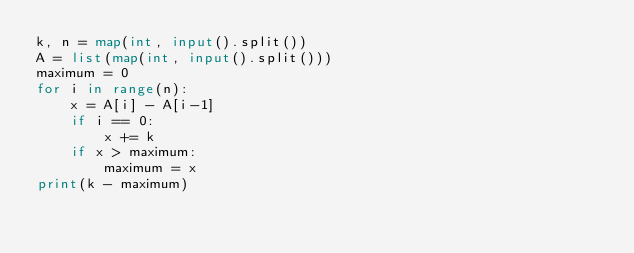Convert code to text. <code><loc_0><loc_0><loc_500><loc_500><_Python_>k, n = map(int, input().split())
A = list(map(int, input().split()))
maximum = 0
for i in range(n):
    x = A[i] - A[i-1]
    if i == 0:
        x += k
    if x > maximum:
        maximum = x
print(k - maximum)
</code> 